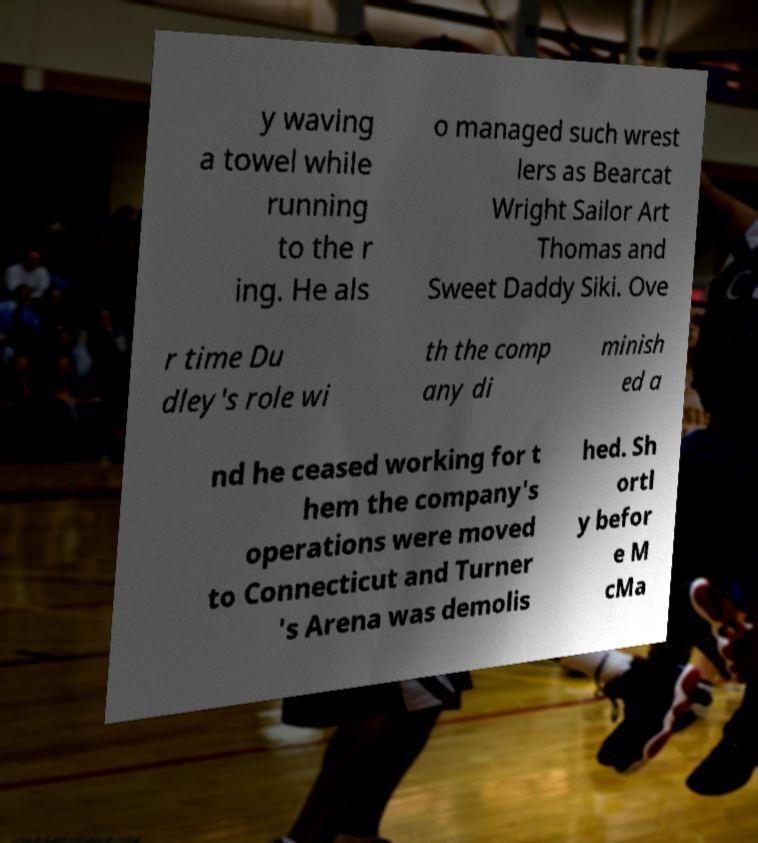For documentation purposes, I need the text within this image transcribed. Could you provide that? y waving a towel while running to the r ing. He als o managed such wrest lers as Bearcat Wright Sailor Art Thomas and Sweet Daddy Siki. Ove r time Du dley's role wi th the comp any di minish ed a nd he ceased working for t hem the company's operations were moved to Connecticut and Turner 's Arena was demolis hed. Sh ortl y befor e M cMa 